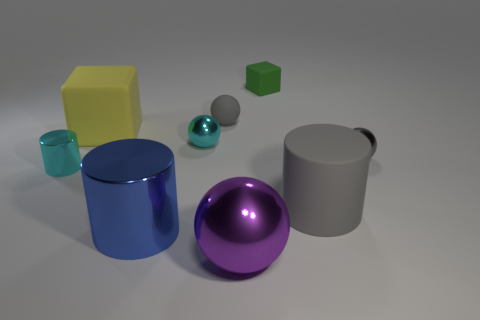Subtract all cubes. How many objects are left? 7 Subtract all small metal cylinders. Subtract all green metal balls. How many objects are left? 8 Add 8 gray cylinders. How many gray cylinders are left? 9 Add 7 small matte blocks. How many small matte blocks exist? 8 Subtract 1 green blocks. How many objects are left? 8 